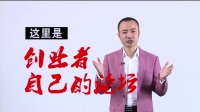Don't forget these rules:
 
1. **Be Direct and Concise**: Provide straightforward descriptions without adding interpretative or speculative elements.
2. **Use Segmented Details**: Break down details about different elements of an image into distinct sentences, focusing on one aspect at a time.
3. **Maintain a Descriptive Focus**: Prioritize purely visible elements of the image, avoiding conclusions or inferences.
4. **Follow a Logical Structure**: Begin with the central figure or subject and expand outward, detailing its appearance before addressing the surrounding setting.
5. **Avoid Juxtaposition**: Do not use comparison or contrast language; keep the description purely factual.
6. **Incorporate Specificity**: Mention age, gender, race, and specific brands or notable features when present, and clearly identify the medium if it's discernible. 
 
When writing descriptions, prioritize clarity and direct observation over embellishment or interpretation.
 
Write a detailed description of this image, do not forget about the texts on it if they exist. Also, do not forget to mention the type / style of the image. No bullet points. This is a still image featuring an individual standing in front of a white background. The person appears to be a middle-aged male, dressed in a pink blazer over a white shirt. His hands are spread outwards, and he has a mild smile on his face, giving an impression of addressing the viewer or an audience. On the top left corner of the image, there are Chinese characters in black text. Additionally, there is a larger phrase in red Chinese calligraphy-style characters superimposed over the central part of the image to the right of the man. The style of the image resembles that of a promotional or informational video still. The text and the person's attire suggest the content may be culturally specific, possibly related to a Chinese-speaking audience. The exact content of the text is not translated as part of the description. 